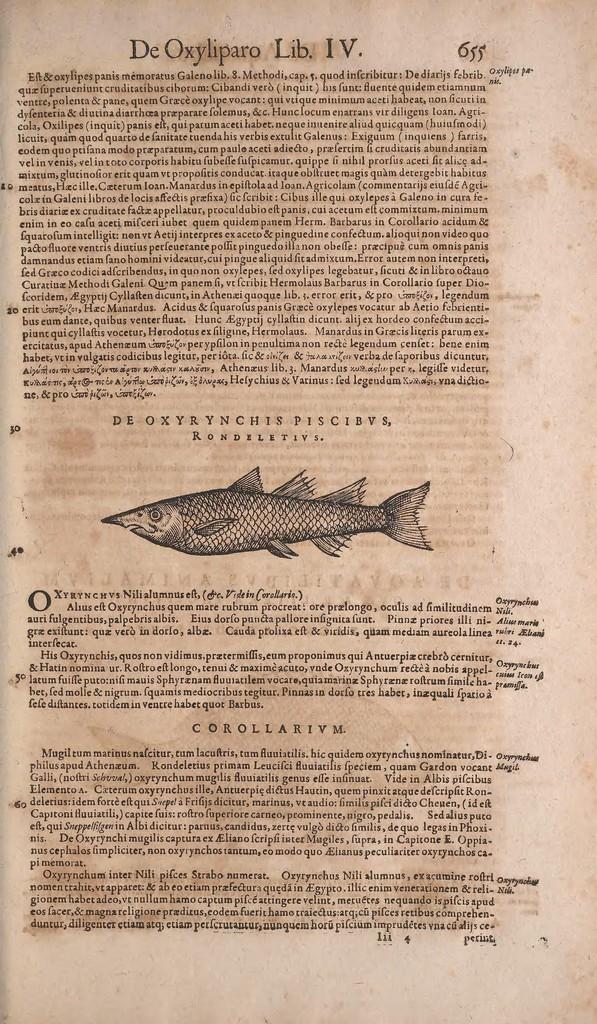Please provide a concise description of this image. This is a paper. I can see the letters and picture of a fish on the paper. 